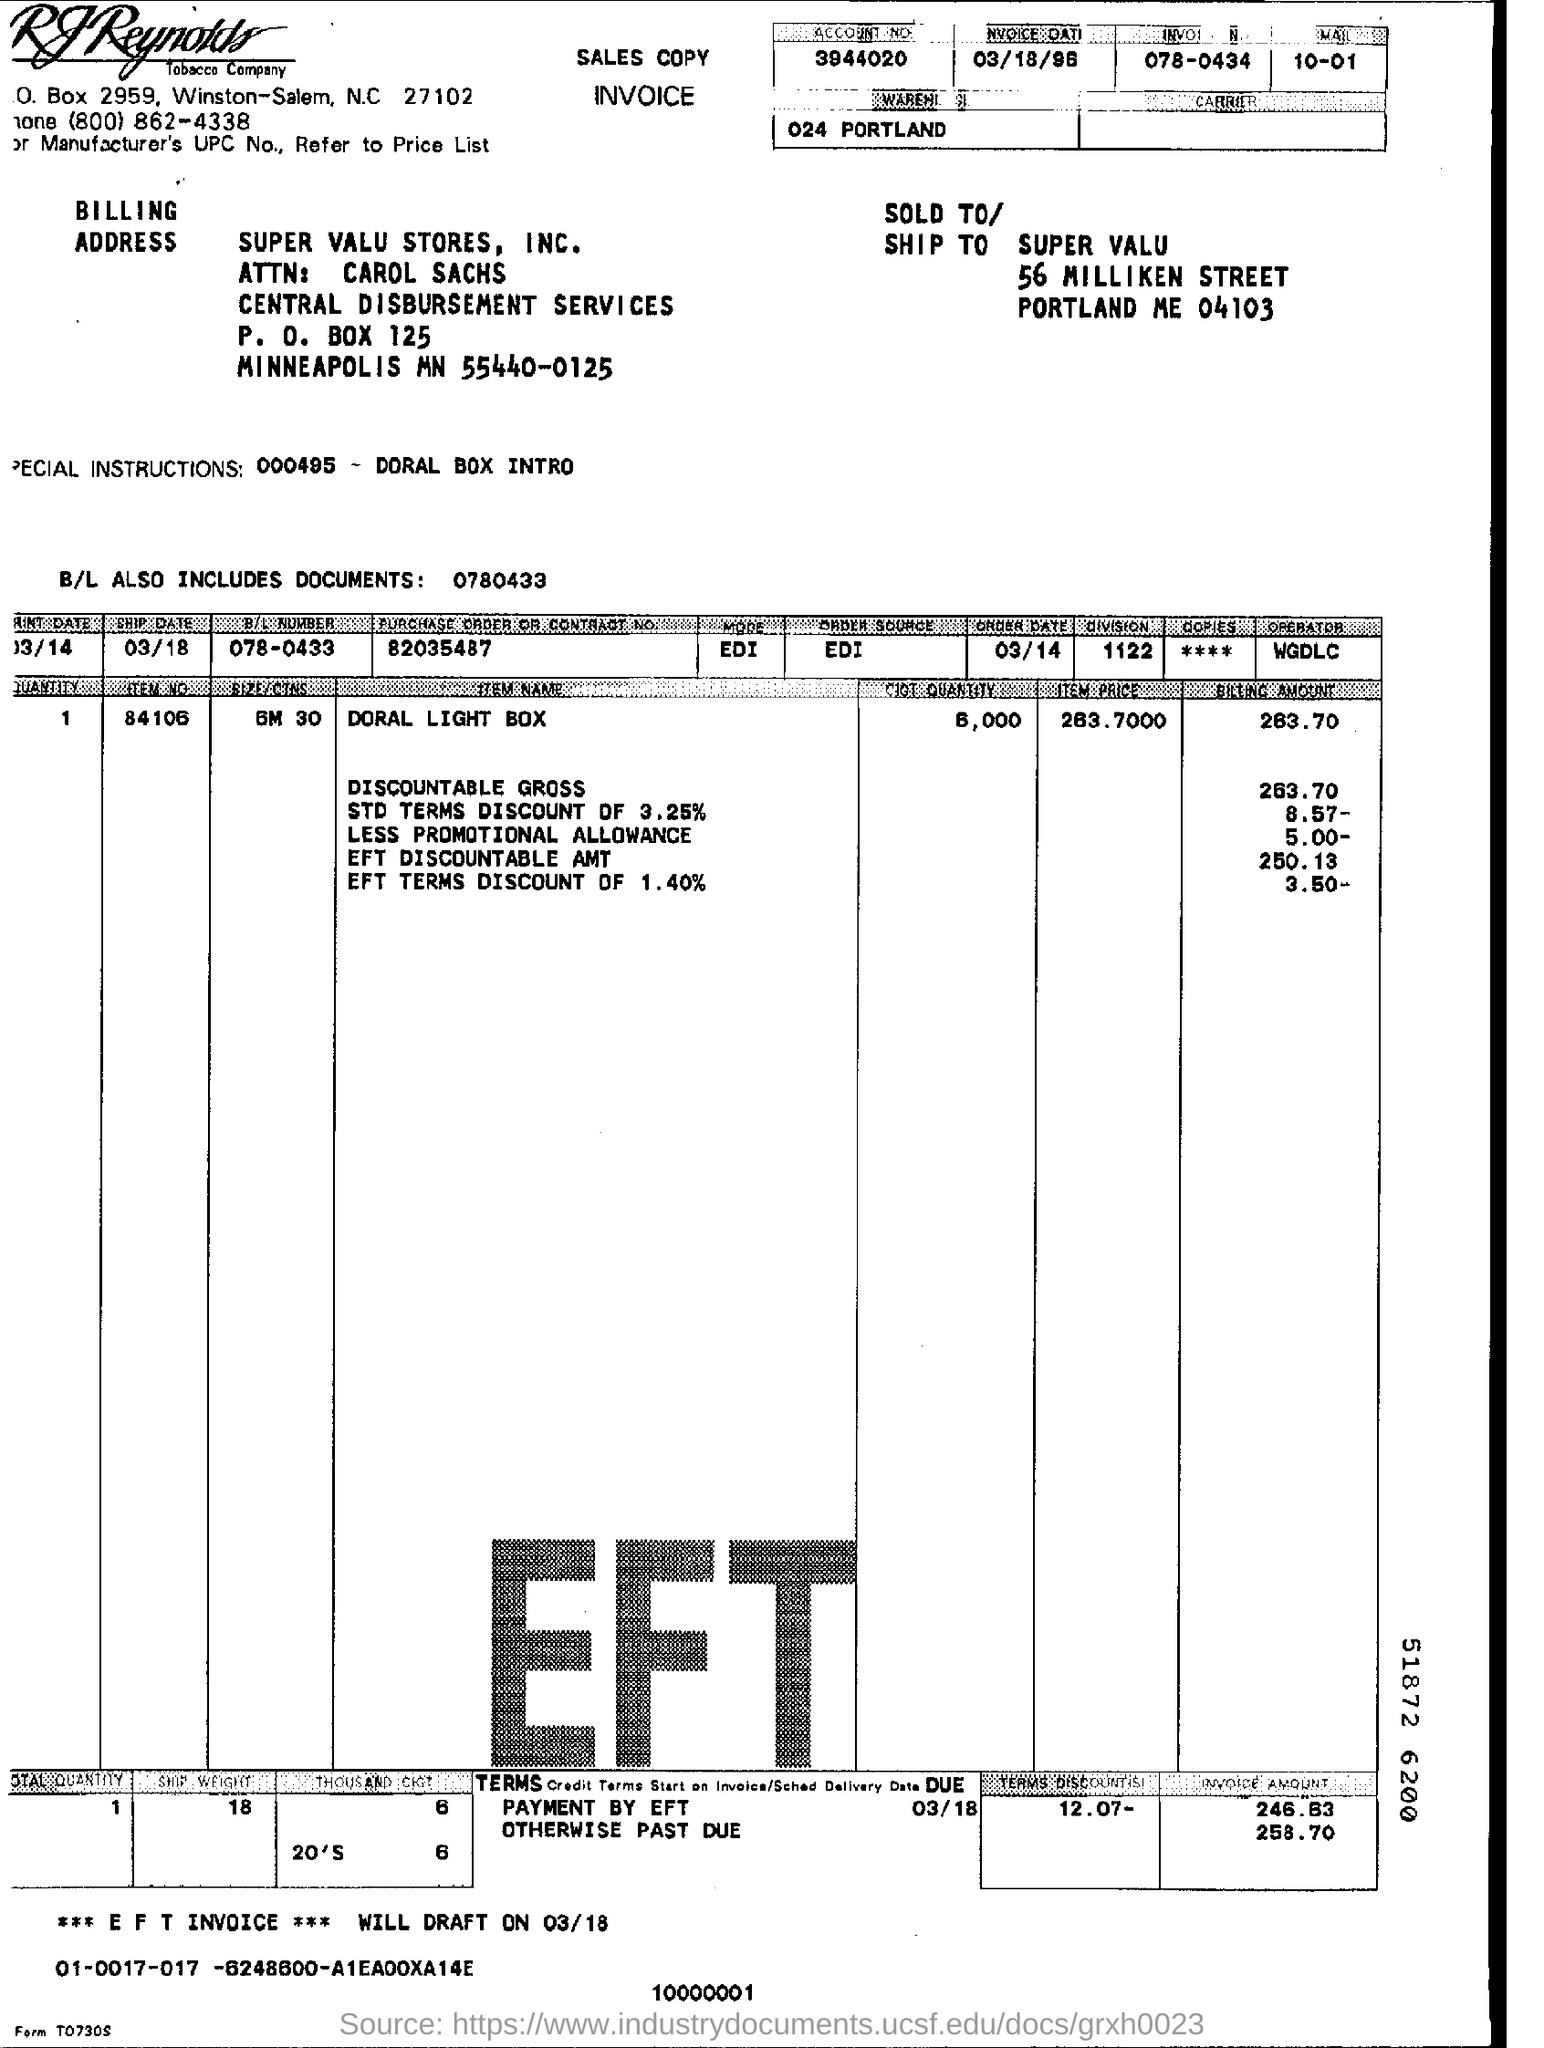What is the Account No.?
Your answer should be compact. 3944020. What is the ship date mentioned in the invoice?
Your response must be concise. 03/18. What is the Purchase order or contract No.?
Offer a very short reply. 82035487. What is the B/L Number?
Offer a terse response. 078-0433. What is the ship date?
Your answer should be compact. 03/18. What is the mode?
Your answer should be compact. EDI. What is the order date?
Give a very brief answer. 03/14. What is the division?
Make the answer very short. 1122. Who is the operator?
Your answer should be very brief. WGDLC. 